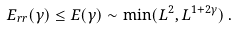<formula> <loc_0><loc_0><loc_500><loc_500>E _ { r r } ( \gamma ) \leq E ( \gamma ) \sim \min ( L ^ { 2 } , L ^ { 1 + 2 \gamma } ) \, .</formula> 